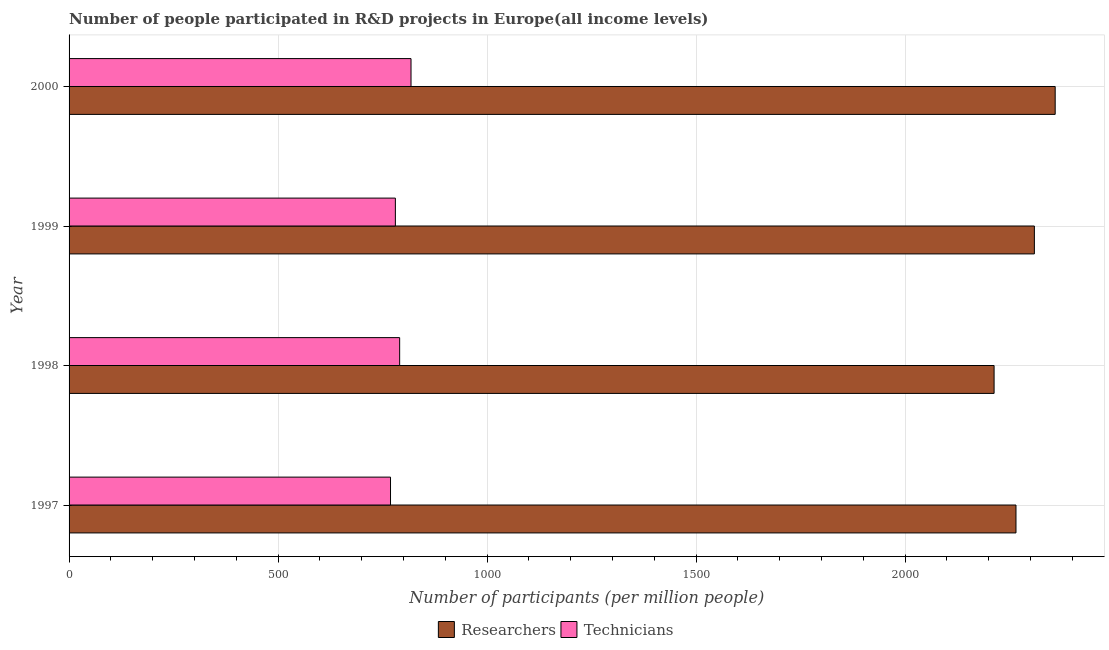Are the number of bars per tick equal to the number of legend labels?
Your answer should be compact. Yes. Are the number of bars on each tick of the Y-axis equal?
Provide a succinct answer. Yes. How many bars are there on the 2nd tick from the bottom?
Offer a terse response. 2. In how many cases, is the number of bars for a given year not equal to the number of legend labels?
Offer a terse response. 0. What is the number of researchers in 1999?
Provide a short and direct response. 2309.44. Across all years, what is the maximum number of technicians?
Ensure brevity in your answer.  818.09. Across all years, what is the minimum number of technicians?
Provide a short and direct response. 769.04. In which year was the number of researchers maximum?
Provide a succinct answer. 2000. What is the total number of technicians in the graph?
Give a very brief answer. 3158.71. What is the difference between the number of researchers in 1999 and that in 2000?
Give a very brief answer. -49.78. What is the difference between the number of technicians in 1999 and the number of researchers in 2000?
Give a very brief answer. -1578.55. What is the average number of technicians per year?
Your answer should be compact. 789.68. In the year 2000, what is the difference between the number of researchers and number of technicians?
Ensure brevity in your answer.  1541.13. What is the ratio of the number of researchers in 1997 to that in 2000?
Your response must be concise. 0.96. What is the difference between the highest and the second highest number of researchers?
Offer a very short reply. 49.78. What is the difference between the highest and the lowest number of researchers?
Keep it short and to the point. 146.17. Is the sum of the number of technicians in 1998 and 2000 greater than the maximum number of researchers across all years?
Give a very brief answer. No. What does the 2nd bar from the top in 1997 represents?
Your answer should be compact. Researchers. What does the 2nd bar from the bottom in 1997 represents?
Offer a very short reply. Technicians. How many bars are there?
Your answer should be very brief. 8. Are all the bars in the graph horizontal?
Your answer should be compact. Yes. What is the difference between two consecutive major ticks on the X-axis?
Give a very brief answer. 500. Does the graph contain any zero values?
Offer a very short reply. No. How are the legend labels stacked?
Offer a very short reply. Horizontal. What is the title of the graph?
Your answer should be very brief. Number of people participated in R&D projects in Europe(all income levels). Does "Gasoline" appear as one of the legend labels in the graph?
Offer a very short reply. No. What is the label or title of the X-axis?
Your answer should be very brief. Number of participants (per million people). What is the Number of participants (per million people) of Researchers in 1997?
Provide a succinct answer. 2265.42. What is the Number of participants (per million people) in Technicians in 1997?
Give a very brief answer. 769.04. What is the Number of participants (per million people) in Researchers in 1998?
Your response must be concise. 2213.05. What is the Number of participants (per million people) in Technicians in 1998?
Offer a very short reply. 790.9. What is the Number of participants (per million people) in Researchers in 1999?
Offer a very short reply. 2309.44. What is the Number of participants (per million people) of Technicians in 1999?
Make the answer very short. 780.67. What is the Number of participants (per million people) in Researchers in 2000?
Keep it short and to the point. 2359.22. What is the Number of participants (per million people) of Technicians in 2000?
Your answer should be very brief. 818.09. Across all years, what is the maximum Number of participants (per million people) of Researchers?
Provide a short and direct response. 2359.22. Across all years, what is the maximum Number of participants (per million people) in Technicians?
Provide a short and direct response. 818.09. Across all years, what is the minimum Number of participants (per million people) in Researchers?
Offer a very short reply. 2213.05. Across all years, what is the minimum Number of participants (per million people) in Technicians?
Your answer should be very brief. 769.04. What is the total Number of participants (per million people) in Researchers in the graph?
Your answer should be very brief. 9147.14. What is the total Number of participants (per million people) of Technicians in the graph?
Offer a terse response. 3158.71. What is the difference between the Number of participants (per million people) in Researchers in 1997 and that in 1998?
Your answer should be very brief. 52.37. What is the difference between the Number of participants (per million people) of Technicians in 1997 and that in 1998?
Your answer should be very brief. -21.86. What is the difference between the Number of participants (per million people) in Researchers in 1997 and that in 1999?
Provide a succinct answer. -44.02. What is the difference between the Number of participants (per million people) of Technicians in 1997 and that in 1999?
Offer a terse response. -11.63. What is the difference between the Number of participants (per million people) in Researchers in 1997 and that in 2000?
Make the answer very short. -93.8. What is the difference between the Number of participants (per million people) of Technicians in 1997 and that in 2000?
Your response must be concise. -49.05. What is the difference between the Number of participants (per million people) in Researchers in 1998 and that in 1999?
Make the answer very short. -96.39. What is the difference between the Number of participants (per million people) in Technicians in 1998 and that in 1999?
Provide a short and direct response. 10.23. What is the difference between the Number of participants (per million people) in Researchers in 1998 and that in 2000?
Offer a very short reply. -146.17. What is the difference between the Number of participants (per million people) of Technicians in 1998 and that in 2000?
Give a very brief answer. -27.19. What is the difference between the Number of participants (per million people) in Researchers in 1999 and that in 2000?
Your answer should be very brief. -49.78. What is the difference between the Number of participants (per million people) in Technicians in 1999 and that in 2000?
Provide a short and direct response. -37.42. What is the difference between the Number of participants (per million people) of Researchers in 1997 and the Number of participants (per million people) of Technicians in 1998?
Your answer should be compact. 1474.52. What is the difference between the Number of participants (per million people) of Researchers in 1997 and the Number of participants (per million people) of Technicians in 1999?
Keep it short and to the point. 1484.75. What is the difference between the Number of participants (per million people) of Researchers in 1997 and the Number of participants (per million people) of Technicians in 2000?
Offer a very short reply. 1447.33. What is the difference between the Number of participants (per million people) in Researchers in 1998 and the Number of participants (per million people) in Technicians in 1999?
Provide a succinct answer. 1432.38. What is the difference between the Number of participants (per million people) of Researchers in 1998 and the Number of participants (per million people) of Technicians in 2000?
Make the answer very short. 1394.96. What is the difference between the Number of participants (per million people) in Researchers in 1999 and the Number of participants (per million people) in Technicians in 2000?
Give a very brief answer. 1491.35. What is the average Number of participants (per million people) in Researchers per year?
Offer a terse response. 2286.79. What is the average Number of participants (per million people) of Technicians per year?
Keep it short and to the point. 789.68. In the year 1997, what is the difference between the Number of participants (per million people) of Researchers and Number of participants (per million people) of Technicians?
Ensure brevity in your answer.  1496.38. In the year 1998, what is the difference between the Number of participants (per million people) in Researchers and Number of participants (per million people) in Technicians?
Your answer should be very brief. 1422.15. In the year 1999, what is the difference between the Number of participants (per million people) of Researchers and Number of participants (per million people) of Technicians?
Your response must be concise. 1528.77. In the year 2000, what is the difference between the Number of participants (per million people) of Researchers and Number of participants (per million people) of Technicians?
Offer a terse response. 1541.13. What is the ratio of the Number of participants (per million people) of Researchers in 1997 to that in 1998?
Your answer should be very brief. 1.02. What is the ratio of the Number of participants (per million people) in Technicians in 1997 to that in 1998?
Your answer should be compact. 0.97. What is the ratio of the Number of participants (per million people) of Researchers in 1997 to that in 1999?
Offer a terse response. 0.98. What is the ratio of the Number of participants (per million people) in Technicians in 1997 to that in 1999?
Make the answer very short. 0.99. What is the ratio of the Number of participants (per million people) of Researchers in 1997 to that in 2000?
Your answer should be compact. 0.96. What is the ratio of the Number of participants (per million people) of Technicians in 1997 to that in 2000?
Offer a very short reply. 0.94. What is the ratio of the Number of participants (per million people) in Researchers in 1998 to that in 1999?
Make the answer very short. 0.96. What is the ratio of the Number of participants (per million people) in Technicians in 1998 to that in 1999?
Give a very brief answer. 1.01. What is the ratio of the Number of participants (per million people) of Researchers in 1998 to that in 2000?
Offer a very short reply. 0.94. What is the ratio of the Number of participants (per million people) of Technicians in 1998 to that in 2000?
Make the answer very short. 0.97. What is the ratio of the Number of participants (per million people) in Researchers in 1999 to that in 2000?
Provide a short and direct response. 0.98. What is the ratio of the Number of participants (per million people) in Technicians in 1999 to that in 2000?
Give a very brief answer. 0.95. What is the difference between the highest and the second highest Number of participants (per million people) in Researchers?
Keep it short and to the point. 49.78. What is the difference between the highest and the second highest Number of participants (per million people) of Technicians?
Give a very brief answer. 27.19. What is the difference between the highest and the lowest Number of participants (per million people) in Researchers?
Provide a short and direct response. 146.17. What is the difference between the highest and the lowest Number of participants (per million people) of Technicians?
Your answer should be compact. 49.05. 